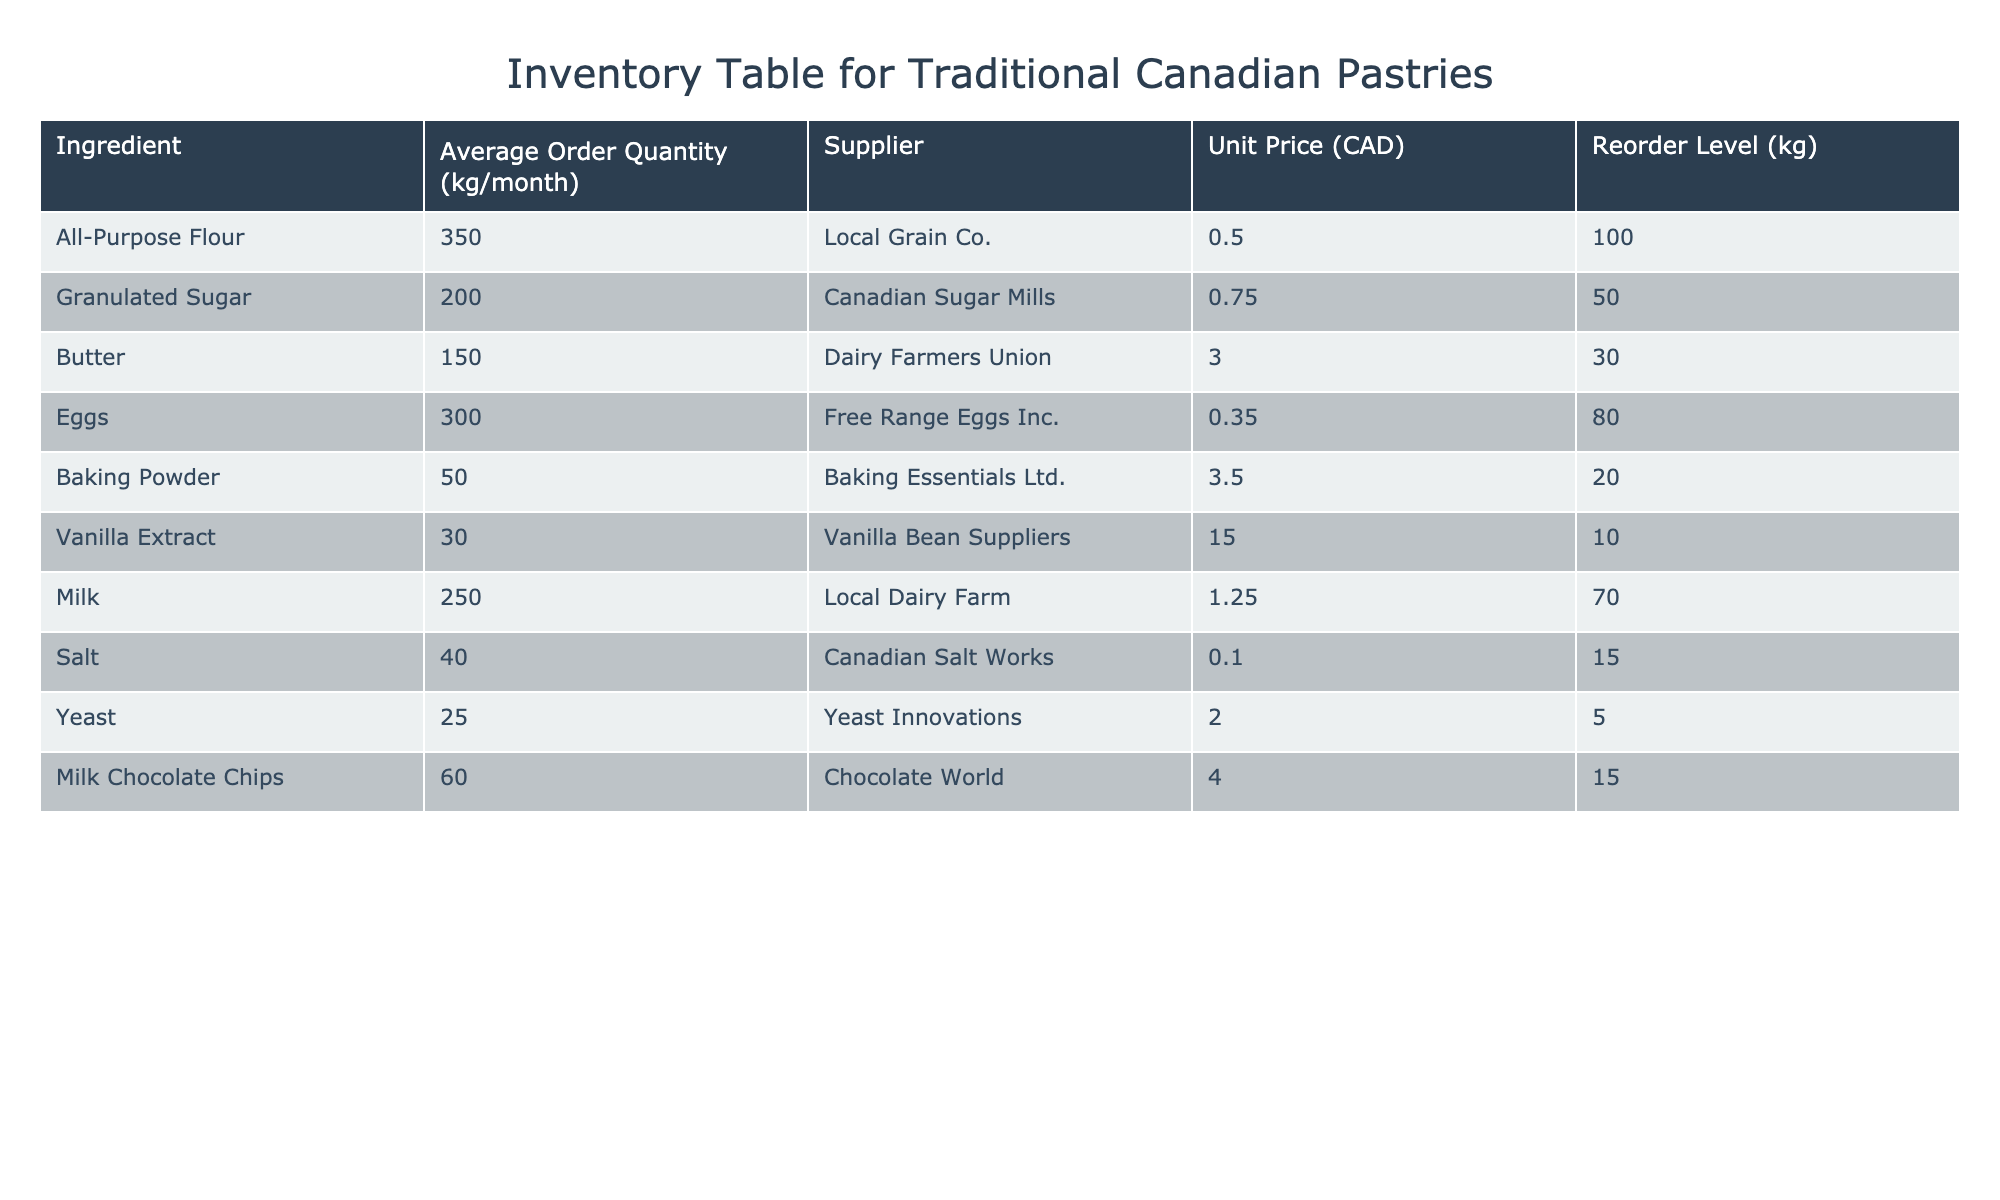What is the average order quantity for All-Purpose Flour? The table indicates that the average order quantity for All-Purpose Flour is listed as 350 kg/month. This is a direct retrieval information from the table.
Answer: 350 kg/month What is the unit price of Vanilla Extract? From the table, the unit price of Vanilla Extract is clearly stated as 15.00 CAD. This is also a direct retrieval from the table.
Answer: 15.00 CAD How much more Granulated Sugar is ordered on average compared to Baking Powder? The average order quantity for Granulated Sugar is 200 kg/month, and Baking Powder is 50 kg/month. The difference is calculated as 200 - 50 = 150 kg/month. This involves basic subtraction.
Answer: 150 kg/month Is the reorder level for Milk higher than that of Butter? The reorder level for Milk is 70 kg and for Butter it is 30 kg. Since 70 is greater than 30, the statement is true. This is a yes/no question based on the comparison of values from the table.
Answer: Yes What is the total average order quantity for all chocolate-related ingredients (Milk Chocolate Chips and Butter)? First, we find the average order quantities: Milk Chocolate Chips is 60 kg/month and Butter is 150 kg/month. We sum them up: 60 + 150 = 210 kg/month. This involves addition of multiple data points.
Answer: 210 kg/month Which ingredient has the lowest average order quantity? Referring to the table, Yeast has the lowest average order quantity at 25 kg/month. This is a direct retrieval from the table where all values have been compared.
Answer: Yeast (25 kg/month) What is the total average order quantity for all liquid ingredients (Milk, Eggs, and Vanilla Extract)? The average order quantities for these ingredients are: Milk 250 kg/month, Eggs 300 kg/month, and Vanilla Extract 30 kg/month. We sum them: 250 + 300 + 30 = 580 kg/month. This question requires addition of multiple values.
Answer: 580 kg/month Is the supplier for Salt the same as that for Sugar? The table shows that Salt is supplied by Canadian Salt Works, while Sugar is supplied by Canadian Sugar Mills. Since these suppliers are different, the statement is false. This is a yes/no question based on direct comparison of supplier names.
Answer: No 